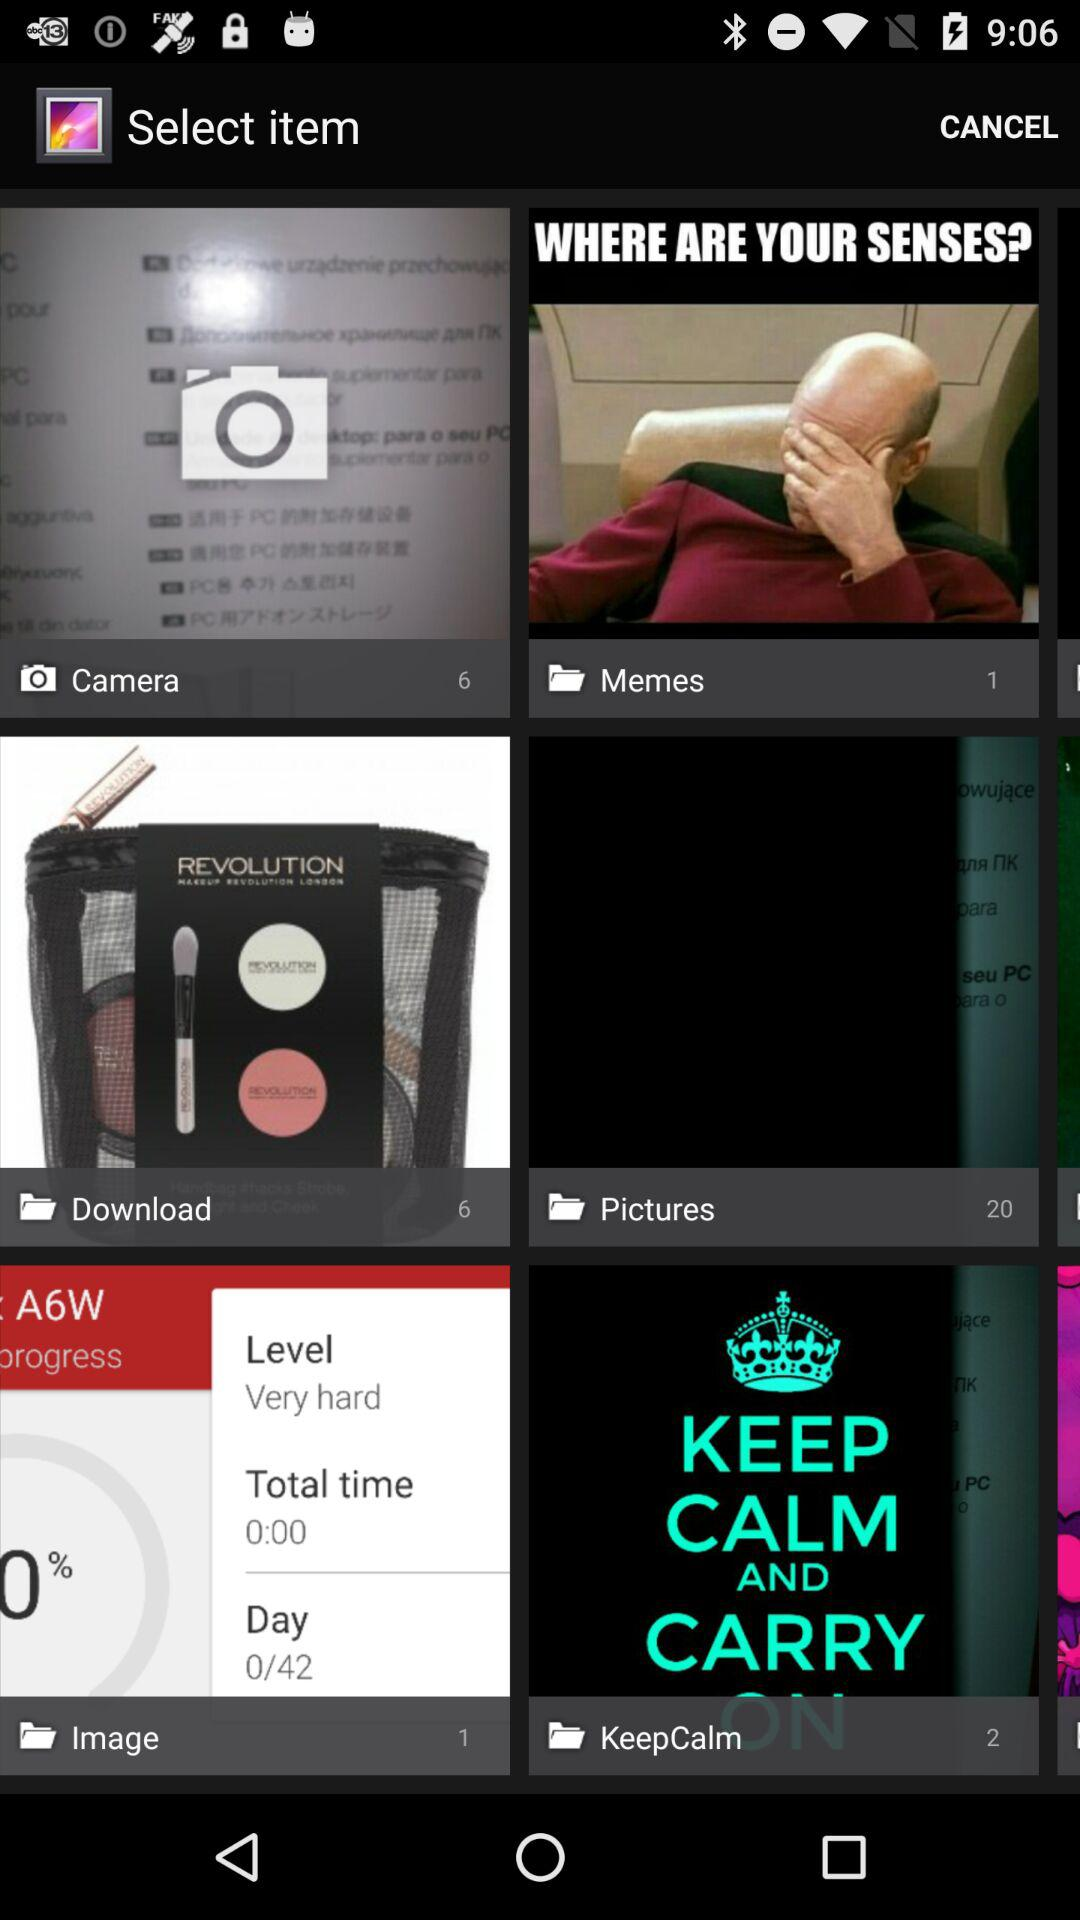How many photos are in the "Pictures" folder? There are 20 photos. 